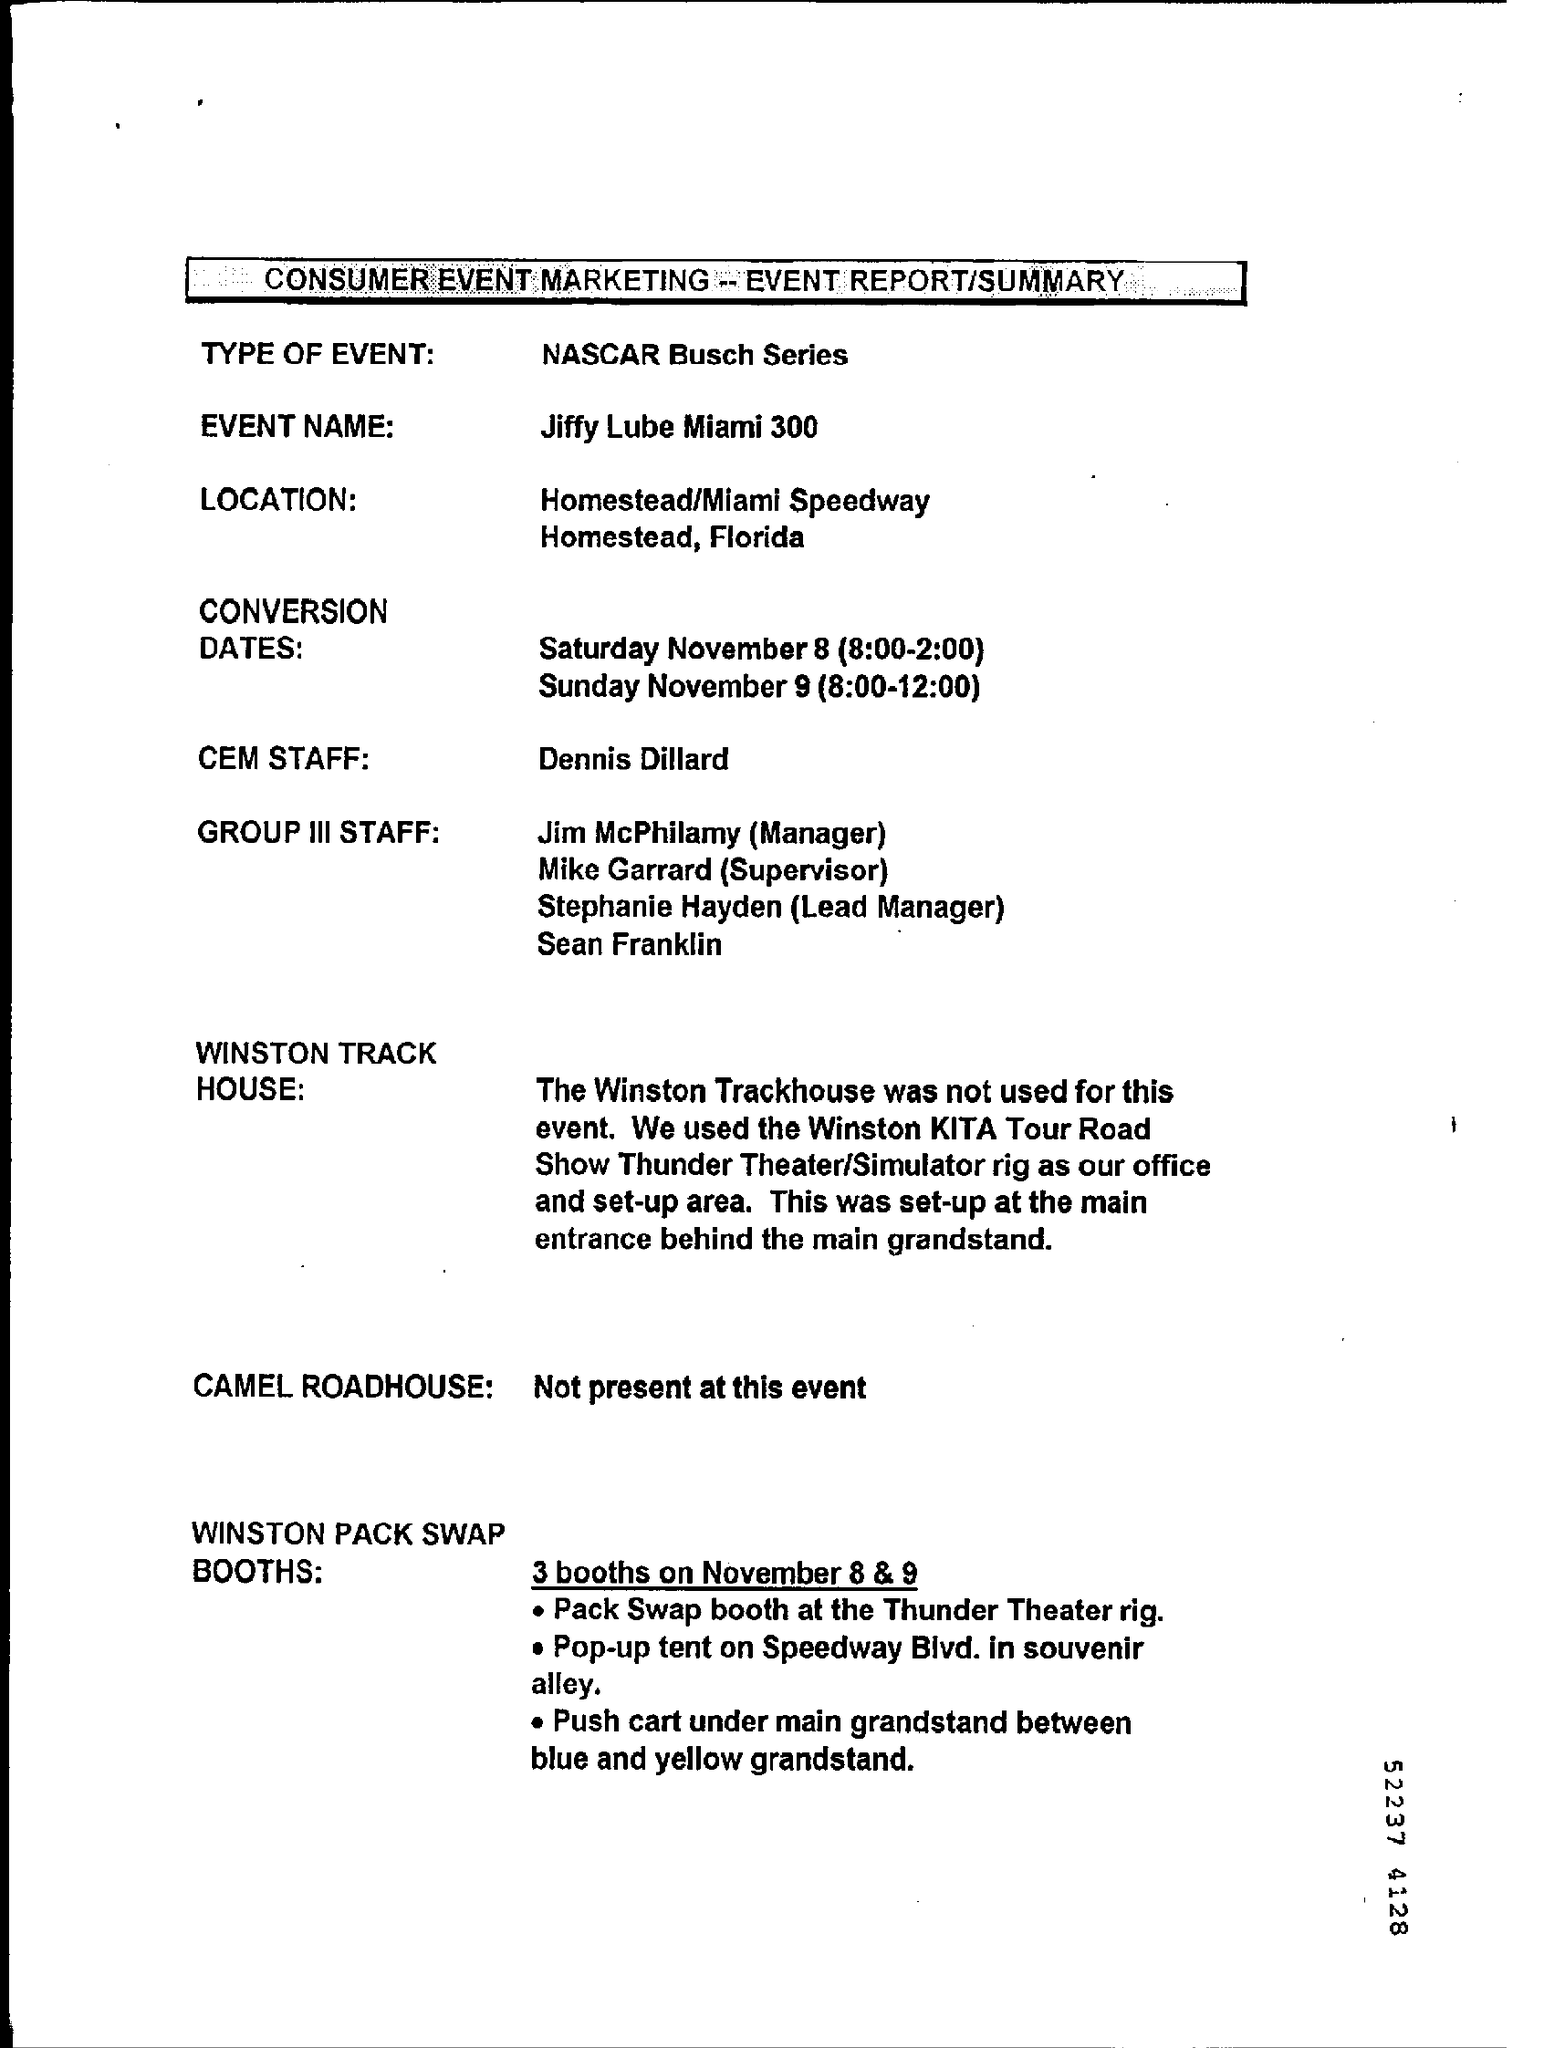Mention a couple of crucial points in this snapshot. On November 8, the time of the program is from 8:00 am to 2:00 pm. The Jiffy Lube Miami 300 is the name of an event. The time of the program on November 9 is 8:00-12:00. The event is described as being of the type NASCAR Busch Series. 